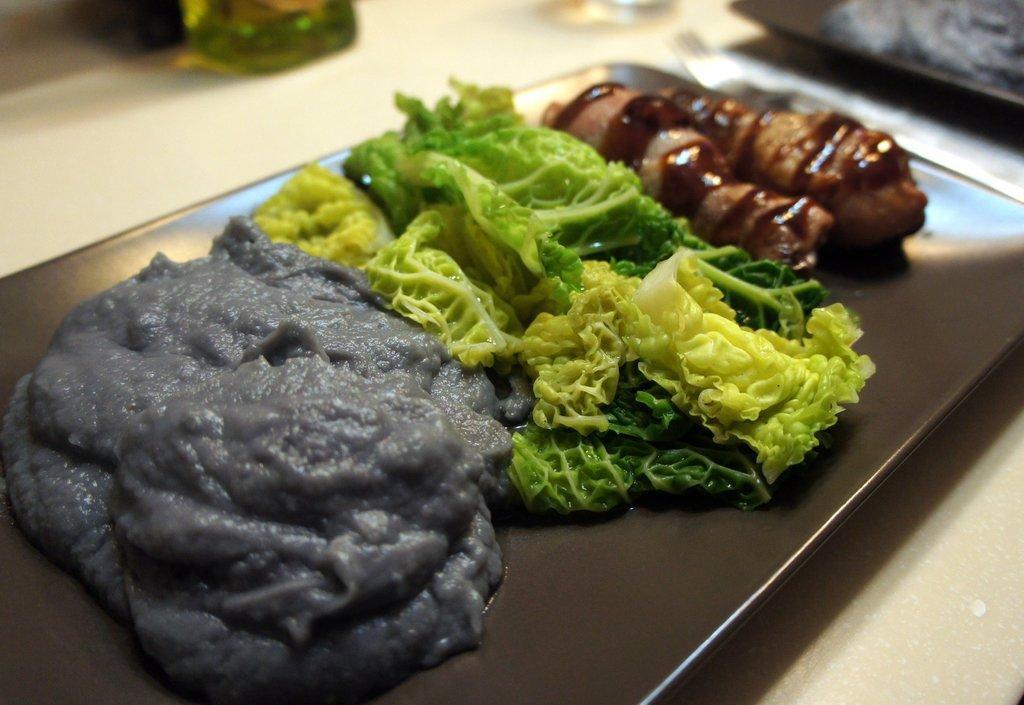In one or two sentences, can you explain what this image depicts? In the picture I can see food items on a black color tray. In the background I can see some other objects. 